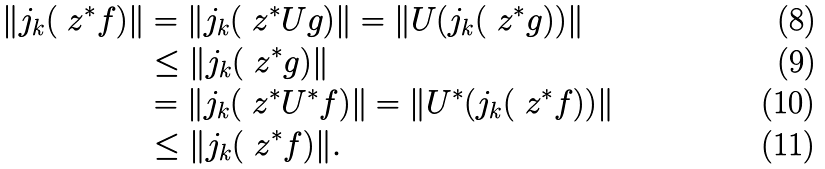Convert formula to latex. <formula><loc_0><loc_0><loc_500><loc_500>\| j _ { k } ( \ z ^ { * } f ) \| & = \| j _ { k } ( \ z ^ { * } U g ) \| = \| U ( j _ { k } ( \ z ^ { * } g ) ) \| \\ & \leq \| j _ { k } ( \ z ^ { * } g ) \| \\ & = \| j _ { k } ( \ z ^ { * } U ^ { * } f ) \| = \| U ^ { * } ( j _ { k } ( \ z ^ { * } f ) ) \| \\ & \leq \| j _ { k } ( \ z ^ { * } f ) \| .</formula> 